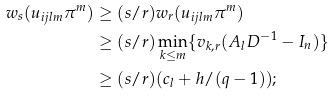Convert formula to latex. <formula><loc_0><loc_0><loc_500><loc_500>w _ { s } ( u _ { i j l m } \pi ^ { m } ) & \geq ( s / r ) w _ { r } ( u _ { i j l m } \pi ^ { m } ) \\ & \geq ( s / r ) \min _ { k \leq m } \{ v _ { k , r } ( A _ { l } D ^ { - 1 } - I _ { n } ) \} \\ & \geq ( s / r ) ( c _ { l } + h / ( q - 1 ) ) ;</formula> 